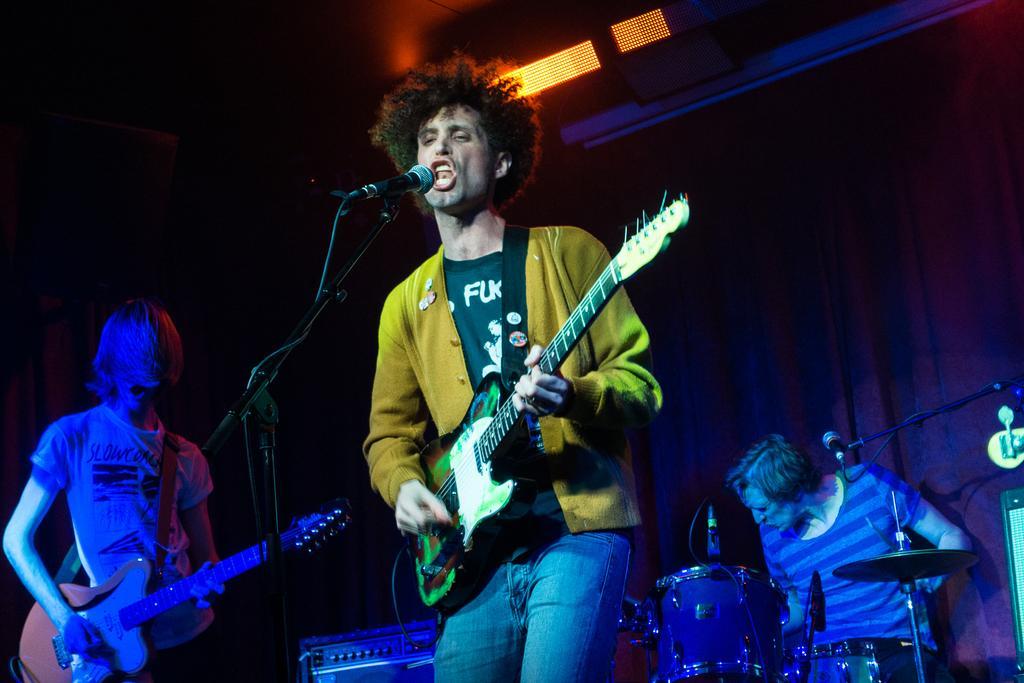Can you describe this image briefly? In this image i can see on the front a person wearing a white color jacket and he holding a guitar his mouth is open and in front of him there is a mike , on the background I can see there are some drumsticks and there is a person playing a drumsticks and on the left side corner a person holding a guitar and standing on the floor. 